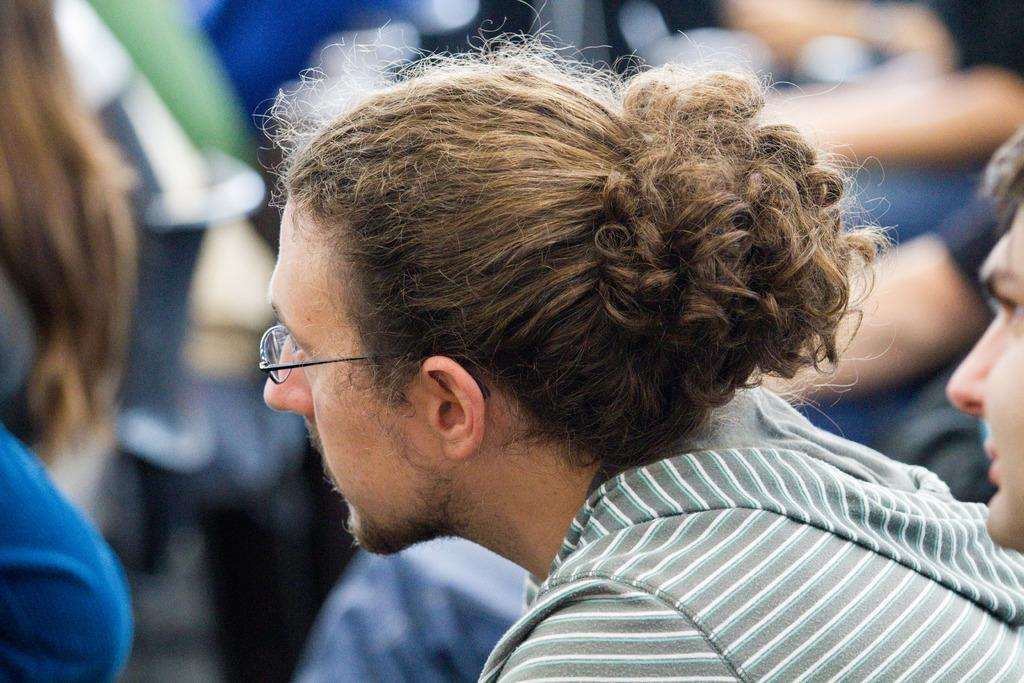What is the person in the image wearing? The person in the image is wearing a grey jacket. What is the person in the image doing? The person is sitting. Can you describe the background of the image? There is a group of people in the background of the image. How would you describe the quality of the image? The image is blurry. How many fingers does the person in the image have on their left hand? There is no information about the person's fingers in the image, as it is blurry and only shows the person wearing a grey jacket while sitting. 